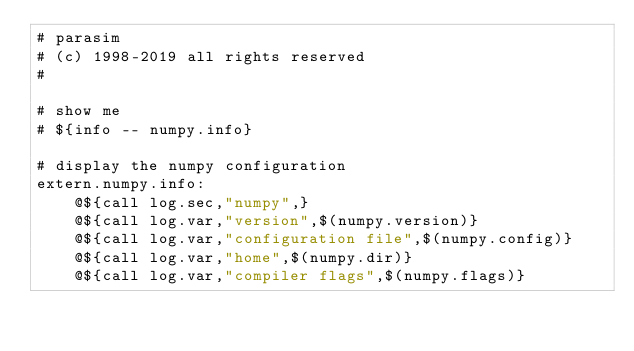<code> <loc_0><loc_0><loc_500><loc_500><_ObjectiveC_># parasim
# (c) 1998-2019 all rights reserved
#

# show me
# ${info -- numpy.info}

# display the numpy configuration
extern.numpy.info:
	@${call log.sec,"numpy",}
	@${call log.var,"version",$(numpy.version)}
	@${call log.var,"configuration file",$(numpy.config)}
	@${call log.var,"home",$(numpy.dir)}
	@${call log.var,"compiler flags",$(numpy.flags)}</code> 